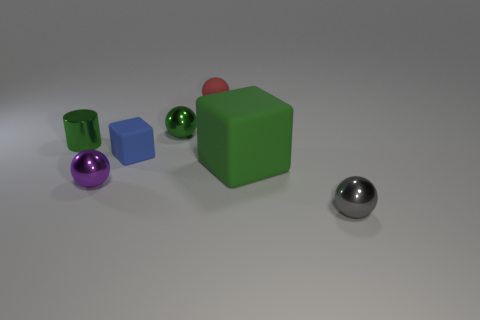What is the size of the green metal object that is the same shape as the gray metal thing?
Give a very brief answer. Small. What is the size of the green shiny object that is to the right of the tiny metal cylinder?
Give a very brief answer. Small. Are there more red spheres that are on the right side of the small red rubber thing than tiny brown things?
Provide a short and direct response. No. What shape is the purple metal object?
Your response must be concise. Sphere. Does the matte block that is on the left side of the small red matte ball have the same color as the rubber thing that is in front of the blue rubber cube?
Your answer should be very brief. No. Is the tiny red matte thing the same shape as the tiny blue object?
Your answer should be compact. No. Is there any other thing that has the same shape as the tiny gray shiny object?
Offer a very short reply. Yes. Does the small green thing that is to the left of the purple object have the same material as the tiny purple object?
Offer a terse response. Yes. What shape is the metallic object that is both to the right of the small purple thing and behind the small purple shiny ball?
Offer a very short reply. Sphere. Is there a tiny object to the left of the object that is right of the big green block?
Offer a terse response. Yes. 